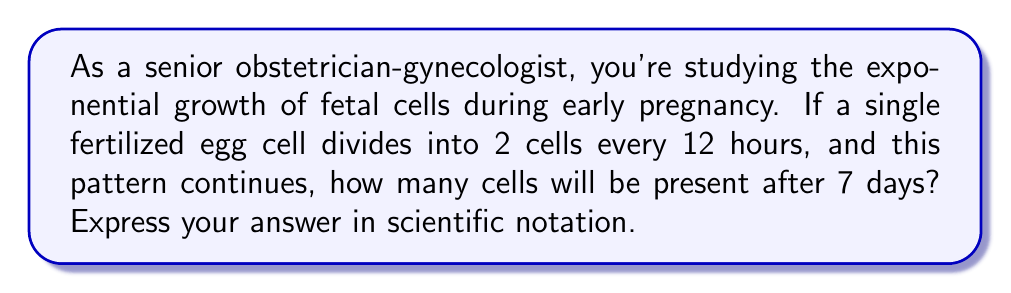Show me your answer to this math problem. Let's approach this step-by-step:

1) First, we need to determine how many 12-hour periods are in 7 days:
   $$ \text{Number of periods} = \frac{7 \text{ days} \times 24 \text{ hours/day}}{12 \text{ hours/period}} = 14 \text{ periods} $$

2) Now, we can set up our exponential growth equation:
   $$ \text{Number of cells} = 2^n $$
   where $n$ is the number of 12-hour periods.

3) Substituting $n = 14$:
   $$ \text{Number of cells} = 2^{14} $$

4) To calculate this:
   $$ 2^{14} = 2 \times 2^{13} = 2 \times 8,192 = 16,384 $$

5) To express this in scientific notation:
   $$ 16,384 = 1.6384 \times 10^4 $$

This exponential growth model is a simplification of the actual fetal cell division process, which becomes more complex as the embryo develops. However, it illustrates the rapid increase in cell numbers during early pregnancy.
Answer: $1.6384 \times 10^4$ cells 